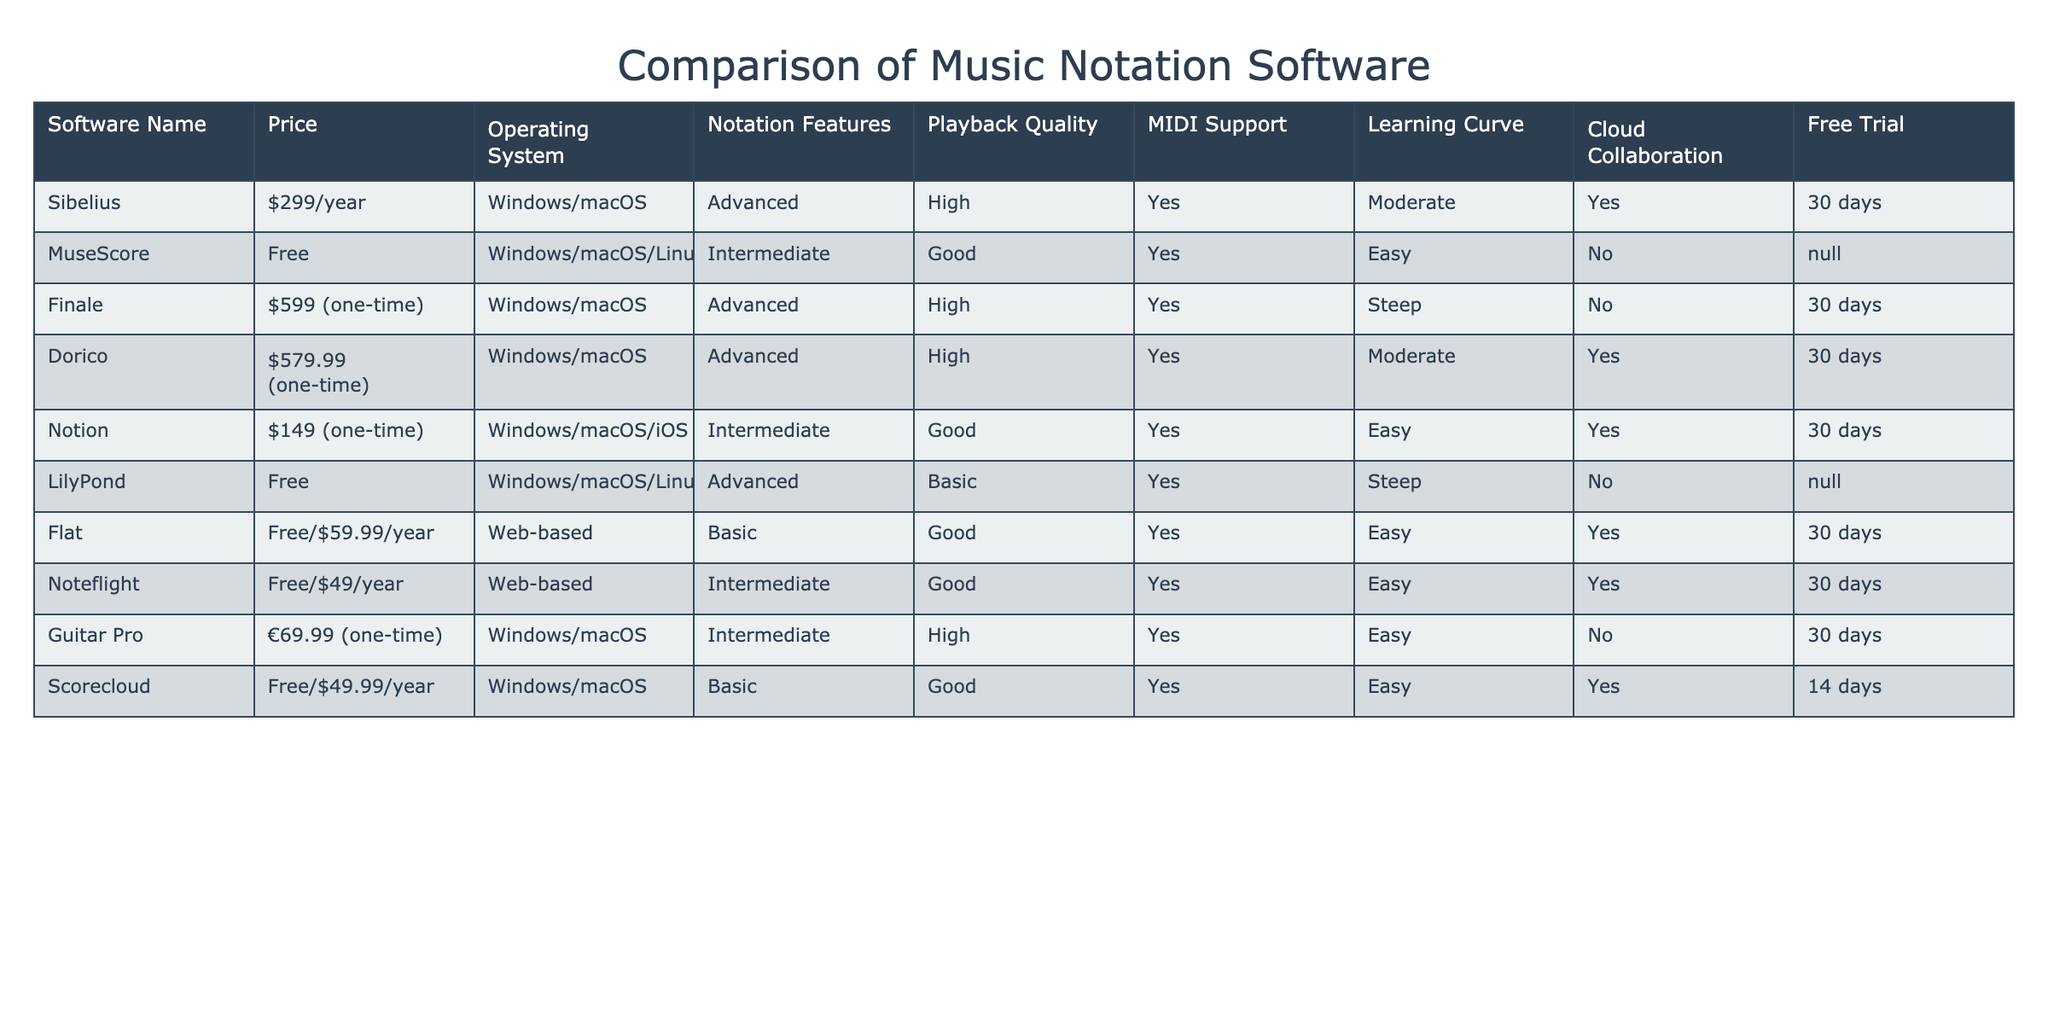What is the price of MuseScore? The table lists MuseScore with a price of "Free" under the Price column.
Answer: Free Which software supports cloud collaboration? In the table, the software names listed under the Cloud Collaboration column with "Yes" are Sibelius, Dorico, Notion, Flat, Noteflight, and Scorecloud.
Answer: Sibelius, Dorico, Notion, Flat, Noteflight, Scorecloud Is the playback quality of Guitar Pro classified as high or low? Looking at the Playback Quality column for Guitar Pro, it shows "High."
Answer: High How many software options are there that offer a free trial period longer than 30 days? Checking the Free Trial column, only Scorecloud offers a trial period of 14 days, which is shorter than all other software. Therefore, no software options have a free trial longer than 30 days.
Answer: 0 Which music notation software has the steepest learning curve? By examining the Learning Curve column, we can see that both Finale and LilyPond are listed as "Steep." Since both have the same rating, they share the distinction of the steepest learning curve.
Answer: Finale, LilyPond What is the total price of the two most expensive software options? The two most expensive software listed are Finale at $599 and Dorico at $579.99. Adding these gives a total of $599 + $579.99 = $1178.99.
Answer: $1178.99 Which software has the best playback quality but no cloud collaboration features? Looking at the Playback Quality column, Sibelius, Finale, Dorico, and Guitar Pro are rated as "High." However, only Guitar Pro does not have cloud collaboration (No in the Cloud Collaboration column).
Answer: Guitar Pro How many software are available for Linux operating system? The table lists MuseScore and LilyPond under the Operating System column, which indicates they both support Linux. Thus, there are 2 software options available for Linux.
Answer: 2 What is the average price of the software that offers a free option? The free options are MuseScore, Flat, Noteflight, and Scorecloud. Their prices are $0, $59.99, $49, and $49.99 respectively. The average price is calculated as (0 + 59.99 + 49 + 49.99) / 4 = 39.745.
Answer: $39.75 